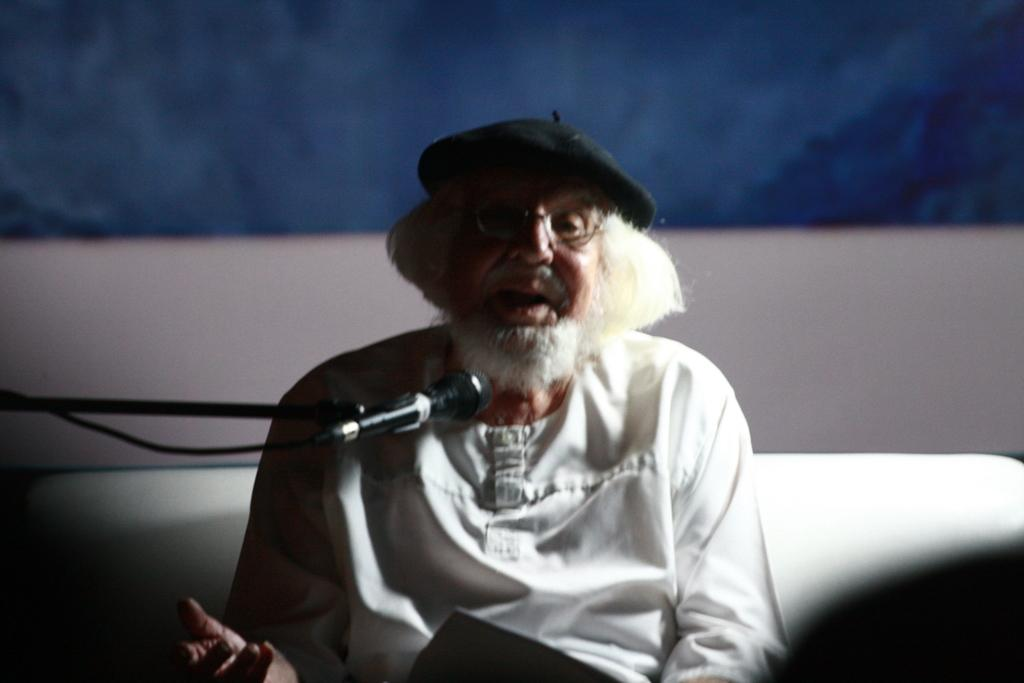Who is the main subject in the image? There is an old man in the image. What object is present in the image that might be used for amplifying sound? There is a microphone with a stand in the image. Can you describe the wall in the image? The wall in the image has white and blue colors. What type of mask is the old man wearing in the image? There is no mask present in the image; the old man is not wearing one. What songs is the old man singing in the image? The image does not show the old man singing, so it cannot be determined which songs he might be singing. 